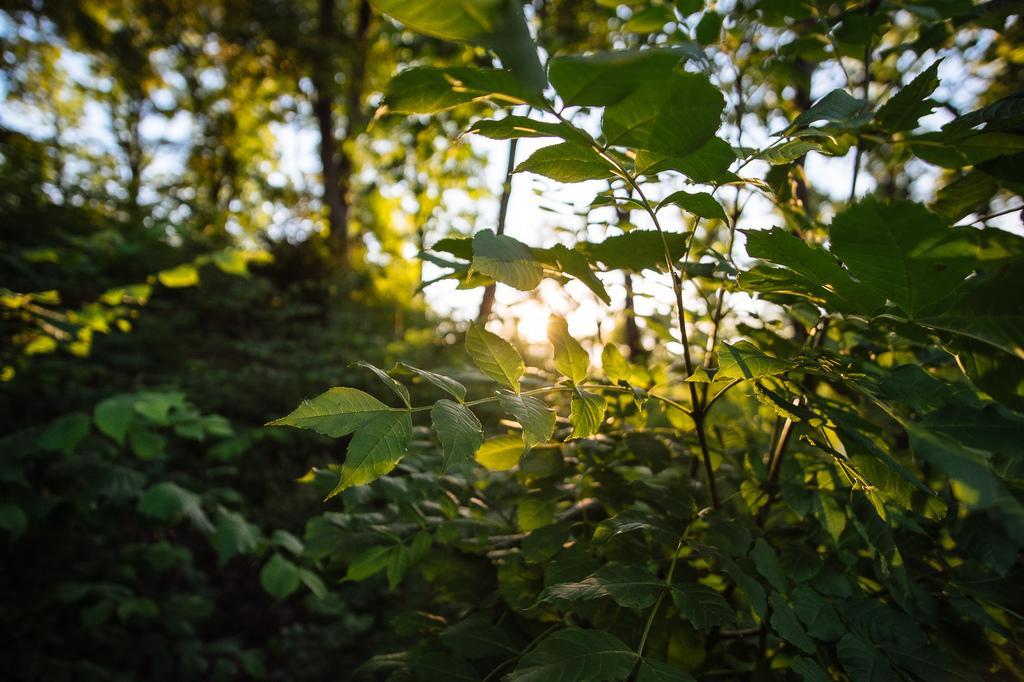Please provide a concise description of this image. In this image we can see plants, trees and sky. 